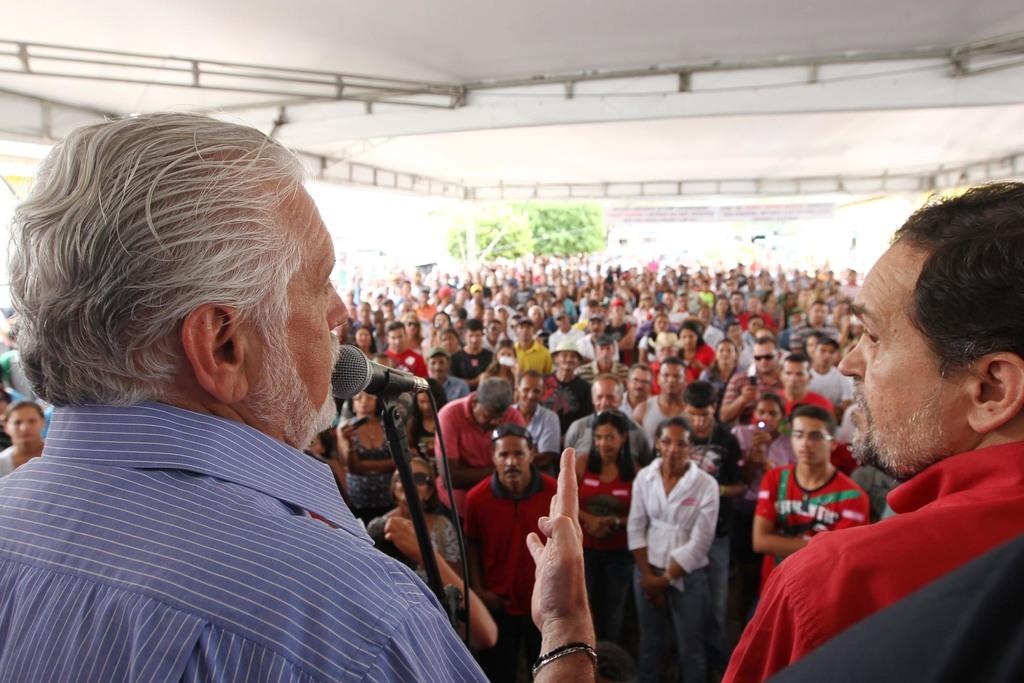What is the man in the image doing? The man is standing in front of a microphone. Can you describe the people in the background? There are people standing in the background. What is visible at the top of the image? There is a roof visible at the top of the image. What type of disease can be seen spreading among the trees in the image? There are no trees present in the image, so it is not possible to determine if any disease is spreading among them. 